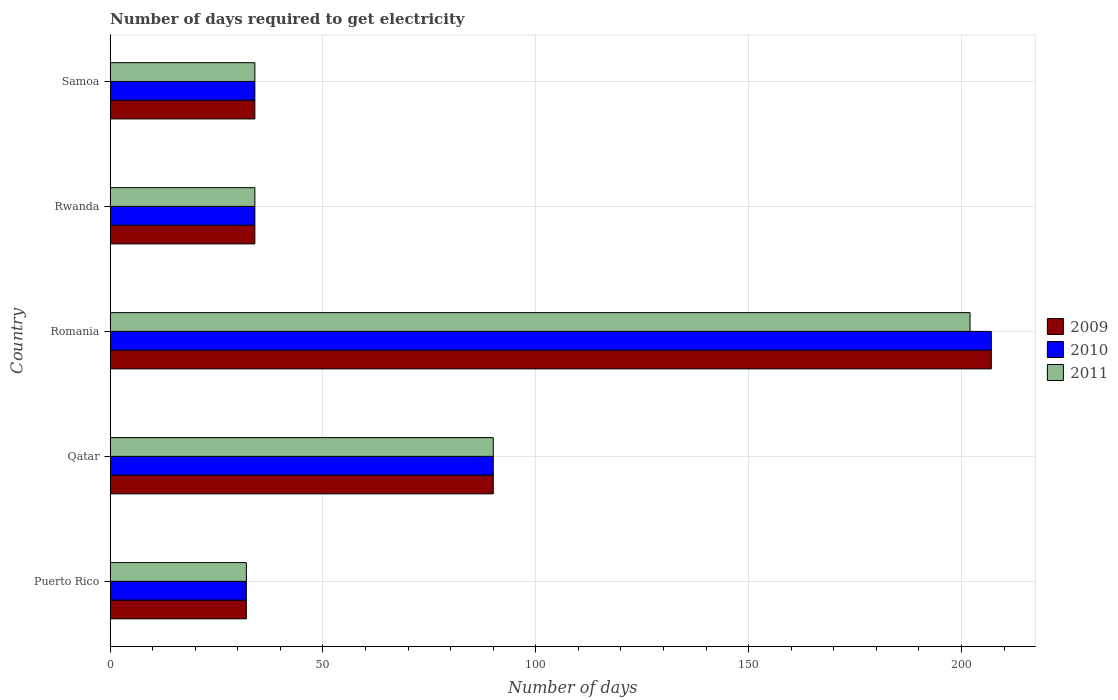How many groups of bars are there?
Offer a very short reply. 5. Are the number of bars per tick equal to the number of legend labels?
Your response must be concise. Yes. How many bars are there on the 1st tick from the bottom?
Your response must be concise. 3. What is the label of the 4th group of bars from the top?
Provide a succinct answer. Qatar. What is the number of days required to get electricity in in 2011 in Qatar?
Your answer should be compact. 90. Across all countries, what is the maximum number of days required to get electricity in in 2010?
Offer a terse response. 207. Across all countries, what is the minimum number of days required to get electricity in in 2009?
Offer a very short reply. 32. In which country was the number of days required to get electricity in in 2010 maximum?
Your response must be concise. Romania. In which country was the number of days required to get electricity in in 2010 minimum?
Ensure brevity in your answer.  Puerto Rico. What is the total number of days required to get electricity in in 2010 in the graph?
Your answer should be very brief. 397. What is the difference between the number of days required to get electricity in in 2011 in Rwanda and the number of days required to get electricity in in 2010 in Qatar?
Provide a succinct answer. -56. What is the average number of days required to get electricity in in 2011 per country?
Offer a terse response. 78.4. What is the difference between the number of days required to get electricity in in 2009 and number of days required to get electricity in in 2011 in Qatar?
Your answer should be very brief. 0. In how many countries, is the number of days required to get electricity in in 2010 greater than 50 days?
Keep it short and to the point. 2. What is the ratio of the number of days required to get electricity in in 2011 in Qatar to that in Samoa?
Your response must be concise. 2.65. Is the difference between the number of days required to get electricity in in 2009 in Puerto Rico and Samoa greater than the difference between the number of days required to get electricity in in 2011 in Puerto Rico and Samoa?
Give a very brief answer. No. What is the difference between the highest and the second highest number of days required to get electricity in in 2009?
Make the answer very short. 117. What is the difference between the highest and the lowest number of days required to get electricity in in 2011?
Offer a terse response. 170. What does the 3rd bar from the top in Qatar represents?
Keep it short and to the point. 2009. What does the 2nd bar from the bottom in Rwanda represents?
Offer a very short reply. 2010. Are all the bars in the graph horizontal?
Make the answer very short. Yes. How many countries are there in the graph?
Provide a succinct answer. 5. Where does the legend appear in the graph?
Your answer should be very brief. Center right. How many legend labels are there?
Your answer should be compact. 3. What is the title of the graph?
Offer a terse response. Number of days required to get electricity. Does "1994" appear as one of the legend labels in the graph?
Ensure brevity in your answer.  No. What is the label or title of the X-axis?
Your response must be concise. Number of days. What is the label or title of the Y-axis?
Provide a short and direct response. Country. What is the Number of days in 2009 in Puerto Rico?
Provide a succinct answer. 32. What is the Number of days in 2010 in Puerto Rico?
Make the answer very short. 32. What is the Number of days of 2011 in Puerto Rico?
Your response must be concise. 32. What is the Number of days of 2009 in Romania?
Your answer should be very brief. 207. What is the Number of days in 2010 in Romania?
Offer a terse response. 207. What is the Number of days of 2011 in Romania?
Your answer should be compact. 202. What is the Number of days in 2010 in Rwanda?
Provide a succinct answer. 34. What is the Number of days in 2011 in Rwanda?
Give a very brief answer. 34. What is the Number of days in 2010 in Samoa?
Offer a very short reply. 34. Across all countries, what is the maximum Number of days of 2009?
Keep it short and to the point. 207. Across all countries, what is the maximum Number of days in 2010?
Your answer should be very brief. 207. Across all countries, what is the maximum Number of days in 2011?
Provide a succinct answer. 202. Across all countries, what is the minimum Number of days of 2011?
Give a very brief answer. 32. What is the total Number of days in 2009 in the graph?
Provide a succinct answer. 397. What is the total Number of days of 2010 in the graph?
Your response must be concise. 397. What is the total Number of days of 2011 in the graph?
Offer a very short reply. 392. What is the difference between the Number of days of 2009 in Puerto Rico and that in Qatar?
Your answer should be very brief. -58. What is the difference between the Number of days in 2010 in Puerto Rico and that in Qatar?
Offer a very short reply. -58. What is the difference between the Number of days in 2011 in Puerto Rico and that in Qatar?
Give a very brief answer. -58. What is the difference between the Number of days of 2009 in Puerto Rico and that in Romania?
Give a very brief answer. -175. What is the difference between the Number of days of 2010 in Puerto Rico and that in Romania?
Your answer should be compact. -175. What is the difference between the Number of days in 2011 in Puerto Rico and that in Romania?
Offer a terse response. -170. What is the difference between the Number of days in 2011 in Puerto Rico and that in Rwanda?
Your response must be concise. -2. What is the difference between the Number of days of 2011 in Puerto Rico and that in Samoa?
Provide a short and direct response. -2. What is the difference between the Number of days in 2009 in Qatar and that in Romania?
Your answer should be very brief. -117. What is the difference between the Number of days in 2010 in Qatar and that in Romania?
Your answer should be very brief. -117. What is the difference between the Number of days in 2011 in Qatar and that in Romania?
Offer a very short reply. -112. What is the difference between the Number of days in 2009 in Qatar and that in Rwanda?
Provide a succinct answer. 56. What is the difference between the Number of days of 2010 in Qatar and that in Rwanda?
Give a very brief answer. 56. What is the difference between the Number of days in 2011 in Qatar and that in Rwanda?
Provide a short and direct response. 56. What is the difference between the Number of days in 2010 in Qatar and that in Samoa?
Keep it short and to the point. 56. What is the difference between the Number of days of 2011 in Qatar and that in Samoa?
Ensure brevity in your answer.  56. What is the difference between the Number of days in 2009 in Romania and that in Rwanda?
Ensure brevity in your answer.  173. What is the difference between the Number of days in 2010 in Romania and that in Rwanda?
Ensure brevity in your answer.  173. What is the difference between the Number of days of 2011 in Romania and that in Rwanda?
Provide a short and direct response. 168. What is the difference between the Number of days of 2009 in Romania and that in Samoa?
Make the answer very short. 173. What is the difference between the Number of days of 2010 in Romania and that in Samoa?
Give a very brief answer. 173. What is the difference between the Number of days of 2011 in Romania and that in Samoa?
Ensure brevity in your answer.  168. What is the difference between the Number of days of 2009 in Puerto Rico and the Number of days of 2010 in Qatar?
Your response must be concise. -58. What is the difference between the Number of days in 2009 in Puerto Rico and the Number of days in 2011 in Qatar?
Make the answer very short. -58. What is the difference between the Number of days of 2010 in Puerto Rico and the Number of days of 2011 in Qatar?
Your response must be concise. -58. What is the difference between the Number of days of 2009 in Puerto Rico and the Number of days of 2010 in Romania?
Offer a very short reply. -175. What is the difference between the Number of days in 2009 in Puerto Rico and the Number of days in 2011 in Romania?
Your answer should be compact. -170. What is the difference between the Number of days of 2010 in Puerto Rico and the Number of days of 2011 in Romania?
Give a very brief answer. -170. What is the difference between the Number of days of 2009 in Puerto Rico and the Number of days of 2010 in Rwanda?
Your answer should be compact. -2. What is the difference between the Number of days in 2010 in Puerto Rico and the Number of days in 2011 in Rwanda?
Provide a succinct answer. -2. What is the difference between the Number of days in 2009 in Puerto Rico and the Number of days in 2010 in Samoa?
Offer a very short reply. -2. What is the difference between the Number of days of 2009 in Puerto Rico and the Number of days of 2011 in Samoa?
Your answer should be very brief. -2. What is the difference between the Number of days in 2010 in Puerto Rico and the Number of days in 2011 in Samoa?
Provide a succinct answer. -2. What is the difference between the Number of days of 2009 in Qatar and the Number of days of 2010 in Romania?
Your answer should be compact. -117. What is the difference between the Number of days in 2009 in Qatar and the Number of days in 2011 in Romania?
Offer a very short reply. -112. What is the difference between the Number of days of 2010 in Qatar and the Number of days of 2011 in Romania?
Offer a terse response. -112. What is the difference between the Number of days in 2009 in Qatar and the Number of days in 2010 in Rwanda?
Ensure brevity in your answer.  56. What is the difference between the Number of days in 2009 in Romania and the Number of days in 2010 in Rwanda?
Make the answer very short. 173. What is the difference between the Number of days in 2009 in Romania and the Number of days in 2011 in Rwanda?
Offer a terse response. 173. What is the difference between the Number of days of 2010 in Romania and the Number of days of 2011 in Rwanda?
Give a very brief answer. 173. What is the difference between the Number of days of 2009 in Romania and the Number of days of 2010 in Samoa?
Your answer should be compact. 173. What is the difference between the Number of days in 2009 in Romania and the Number of days in 2011 in Samoa?
Your response must be concise. 173. What is the difference between the Number of days of 2010 in Romania and the Number of days of 2011 in Samoa?
Offer a very short reply. 173. What is the difference between the Number of days of 2009 in Rwanda and the Number of days of 2011 in Samoa?
Offer a very short reply. 0. What is the difference between the Number of days in 2010 in Rwanda and the Number of days in 2011 in Samoa?
Your answer should be very brief. 0. What is the average Number of days in 2009 per country?
Make the answer very short. 79.4. What is the average Number of days of 2010 per country?
Keep it short and to the point. 79.4. What is the average Number of days of 2011 per country?
Give a very brief answer. 78.4. What is the difference between the Number of days in 2009 and Number of days in 2010 in Puerto Rico?
Keep it short and to the point. 0. What is the difference between the Number of days in 2009 and Number of days in 2011 in Puerto Rico?
Offer a very short reply. 0. What is the difference between the Number of days in 2010 and Number of days in 2011 in Puerto Rico?
Ensure brevity in your answer.  0. What is the difference between the Number of days of 2009 and Number of days of 2010 in Qatar?
Offer a very short reply. 0. What is the difference between the Number of days of 2010 and Number of days of 2011 in Qatar?
Ensure brevity in your answer.  0. What is the difference between the Number of days of 2009 and Number of days of 2011 in Romania?
Keep it short and to the point. 5. What is the difference between the Number of days in 2009 and Number of days in 2011 in Rwanda?
Give a very brief answer. 0. What is the ratio of the Number of days in 2009 in Puerto Rico to that in Qatar?
Provide a succinct answer. 0.36. What is the ratio of the Number of days of 2010 in Puerto Rico to that in Qatar?
Provide a short and direct response. 0.36. What is the ratio of the Number of days in 2011 in Puerto Rico to that in Qatar?
Provide a succinct answer. 0.36. What is the ratio of the Number of days in 2009 in Puerto Rico to that in Romania?
Keep it short and to the point. 0.15. What is the ratio of the Number of days in 2010 in Puerto Rico to that in Romania?
Your answer should be compact. 0.15. What is the ratio of the Number of days in 2011 in Puerto Rico to that in Romania?
Make the answer very short. 0.16. What is the ratio of the Number of days of 2009 in Puerto Rico to that in Rwanda?
Your answer should be very brief. 0.94. What is the ratio of the Number of days in 2010 in Puerto Rico to that in Rwanda?
Offer a very short reply. 0.94. What is the ratio of the Number of days of 2011 in Puerto Rico to that in Rwanda?
Make the answer very short. 0.94. What is the ratio of the Number of days of 2010 in Puerto Rico to that in Samoa?
Provide a succinct answer. 0.94. What is the ratio of the Number of days of 2009 in Qatar to that in Romania?
Ensure brevity in your answer.  0.43. What is the ratio of the Number of days in 2010 in Qatar to that in Romania?
Offer a very short reply. 0.43. What is the ratio of the Number of days in 2011 in Qatar to that in Romania?
Ensure brevity in your answer.  0.45. What is the ratio of the Number of days of 2009 in Qatar to that in Rwanda?
Offer a very short reply. 2.65. What is the ratio of the Number of days in 2010 in Qatar to that in Rwanda?
Provide a succinct answer. 2.65. What is the ratio of the Number of days of 2011 in Qatar to that in Rwanda?
Your response must be concise. 2.65. What is the ratio of the Number of days in 2009 in Qatar to that in Samoa?
Keep it short and to the point. 2.65. What is the ratio of the Number of days of 2010 in Qatar to that in Samoa?
Ensure brevity in your answer.  2.65. What is the ratio of the Number of days in 2011 in Qatar to that in Samoa?
Your answer should be compact. 2.65. What is the ratio of the Number of days in 2009 in Romania to that in Rwanda?
Your answer should be compact. 6.09. What is the ratio of the Number of days in 2010 in Romania to that in Rwanda?
Give a very brief answer. 6.09. What is the ratio of the Number of days in 2011 in Romania to that in Rwanda?
Make the answer very short. 5.94. What is the ratio of the Number of days of 2009 in Romania to that in Samoa?
Make the answer very short. 6.09. What is the ratio of the Number of days of 2010 in Romania to that in Samoa?
Make the answer very short. 6.09. What is the ratio of the Number of days in 2011 in Romania to that in Samoa?
Make the answer very short. 5.94. What is the ratio of the Number of days in 2009 in Rwanda to that in Samoa?
Keep it short and to the point. 1. What is the ratio of the Number of days in 2010 in Rwanda to that in Samoa?
Keep it short and to the point. 1. What is the ratio of the Number of days in 2011 in Rwanda to that in Samoa?
Ensure brevity in your answer.  1. What is the difference between the highest and the second highest Number of days of 2009?
Ensure brevity in your answer.  117. What is the difference between the highest and the second highest Number of days in 2010?
Keep it short and to the point. 117. What is the difference between the highest and the second highest Number of days in 2011?
Ensure brevity in your answer.  112. What is the difference between the highest and the lowest Number of days in 2009?
Your answer should be compact. 175. What is the difference between the highest and the lowest Number of days of 2010?
Provide a succinct answer. 175. What is the difference between the highest and the lowest Number of days of 2011?
Your response must be concise. 170. 